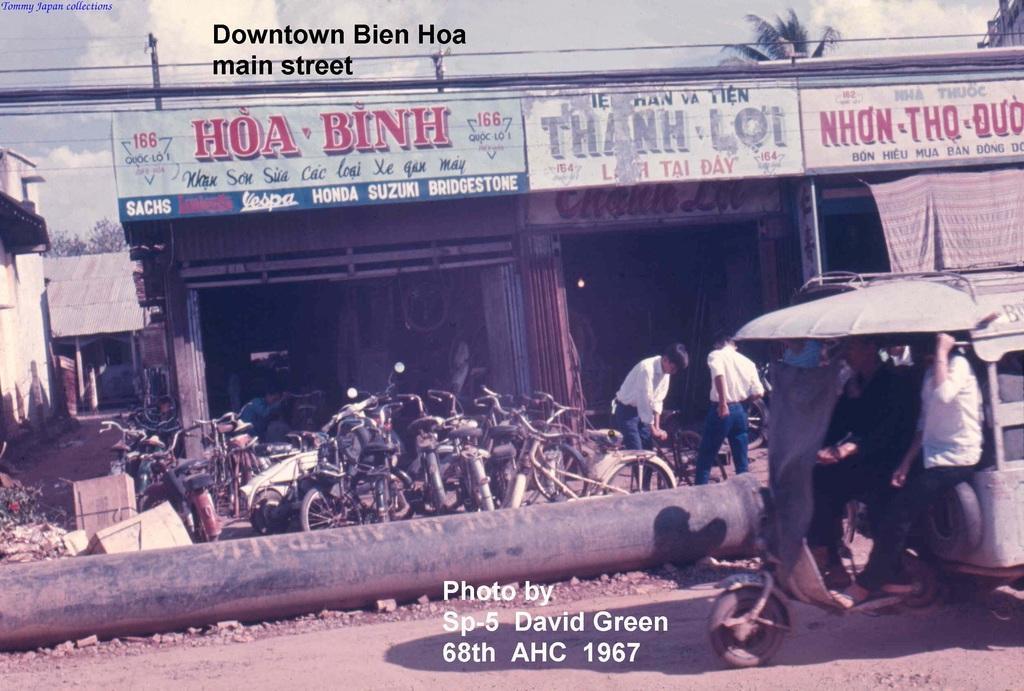Please provide a concise description of this image. In the center of the image we can see a group of cycles placed on the ground. Two persons are standing. To the right side of the image we can see some persons sitting in a vehicle. In the foreground we can see a pipe. In the background, we can see a building with some sign boards and text on them, a tree and the sky. 